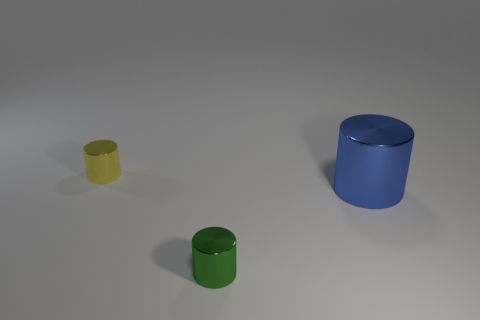Add 3 large objects. How many objects exist? 6 Add 3 yellow shiny objects. How many yellow shiny objects exist? 4 Subtract 1 yellow cylinders. How many objects are left? 2 Subtract all green shiny objects. Subtract all big metal cylinders. How many objects are left? 1 Add 2 large blue cylinders. How many large blue cylinders are left? 3 